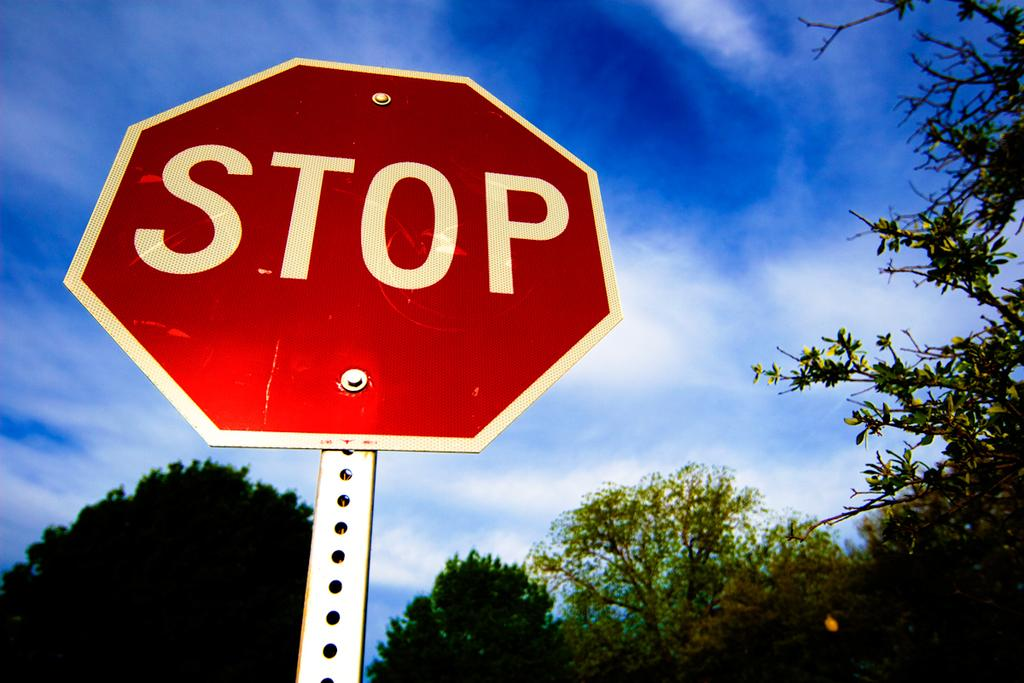Provide a one-sentence caption for the provided image. Red octagon sign with STOP in white letters on a silver pole. 